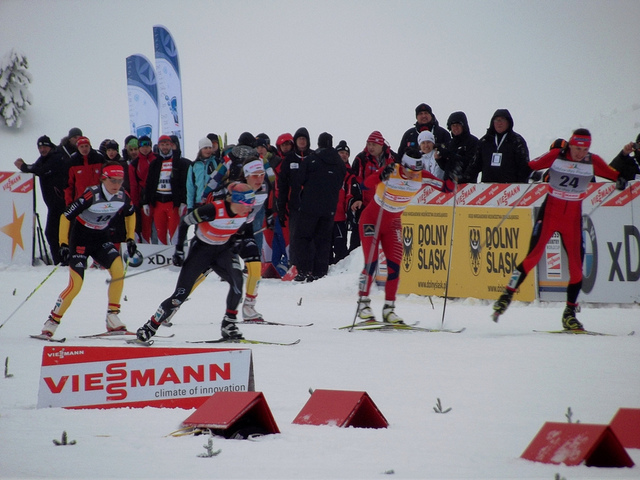Describe the weather conditions the competitors are facing in this event. The athletes are competing under overcast skies, with a white blanket of snow covering the ground, which suggests cold and possibly windy conditions – typical of cross-country ski races. 